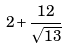<formula> <loc_0><loc_0><loc_500><loc_500>2 + \frac { 1 2 } { \sqrt { 1 3 } }</formula> 